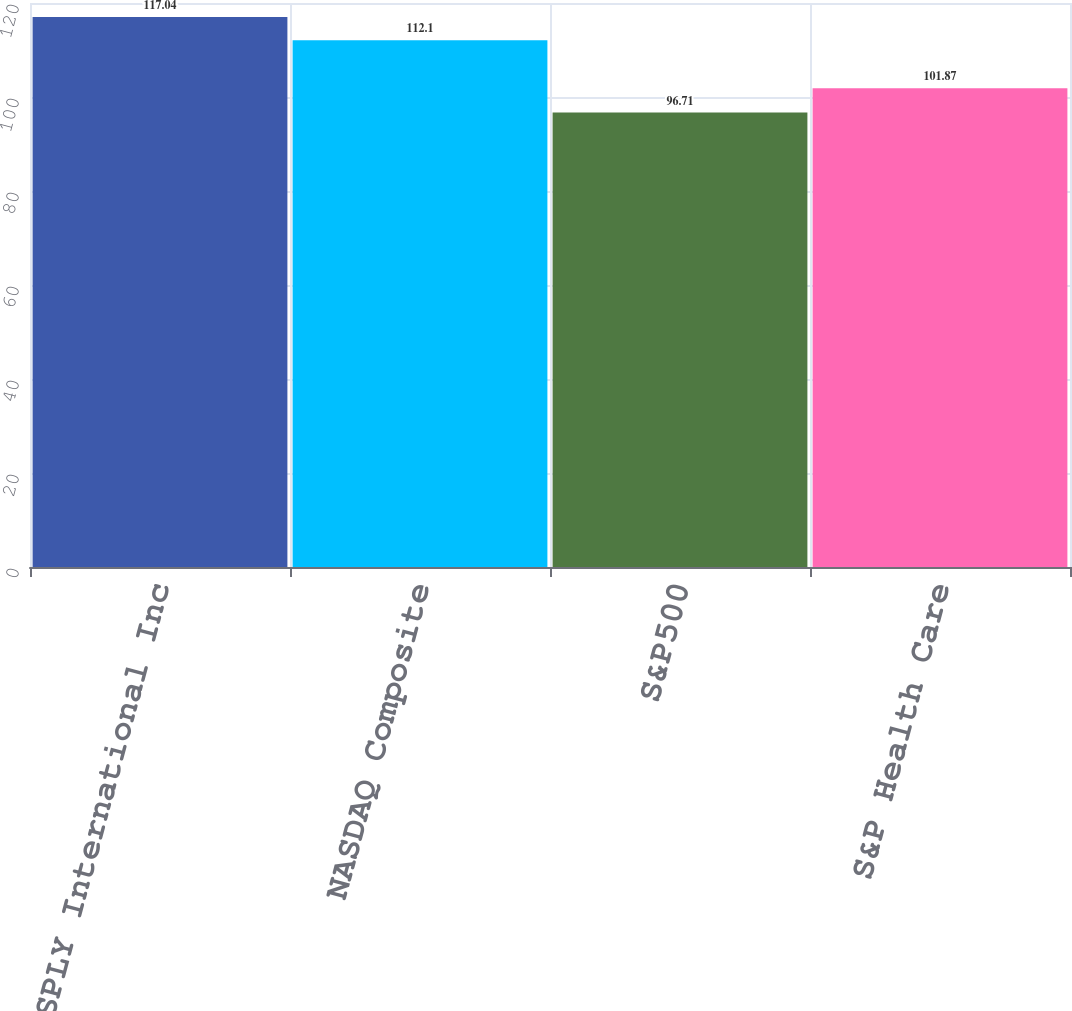Convert chart to OTSL. <chart><loc_0><loc_0><loc_500><loc_500><bar_chart><fcel>DENTSPLY International Inc<fcel>NASDAQ Composite<fcel>S&P500<fcel>S&P Health Care<nl><fcel>117.04<fcel>112.1<fcel>96.71<fcel>101.87<nl></chart> 